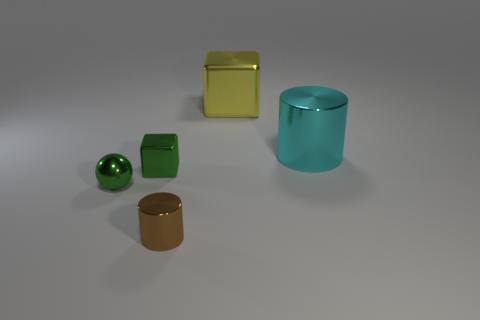Subtract all cylinders. How many objects are left? 3 Add 4 red metal blocks. How many objects exist? 9 Subtract all small spheres. Subtract all shiny blocks. How many objects are left? 2 Add 4 small green shiny blocks. How many small green shiny blocks are left? 5 Add 2 cyan cylinders. How many cyan cylinders exist? 3 Subtract 0 gray spheres. How many objects are left? 5 Subtract 1 cubes. How many cubes are left? 1 Subtract all yellow blocks. Subtract all brown spheres. How many blocks are left? 1 Subtract all red spheres. How many yellow blocks are left? 1 